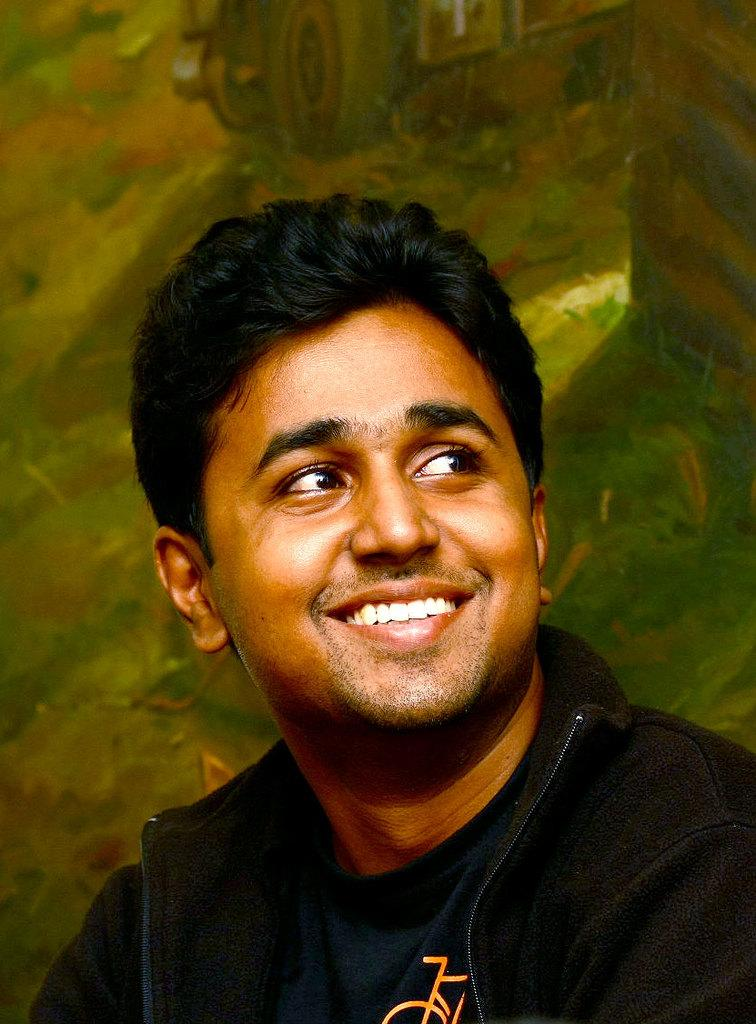What can be seen in the image? There is a person in the image. How is the person's expression in the image? The person is smiling. What is visible in the background of the image? There is a wall poster in the background of the image. What type of cream is being used by the creature in the image? There is no creature or cream present in the image. How many loaves of bread are visible in the image? There are no loaves of bread present in the image. 